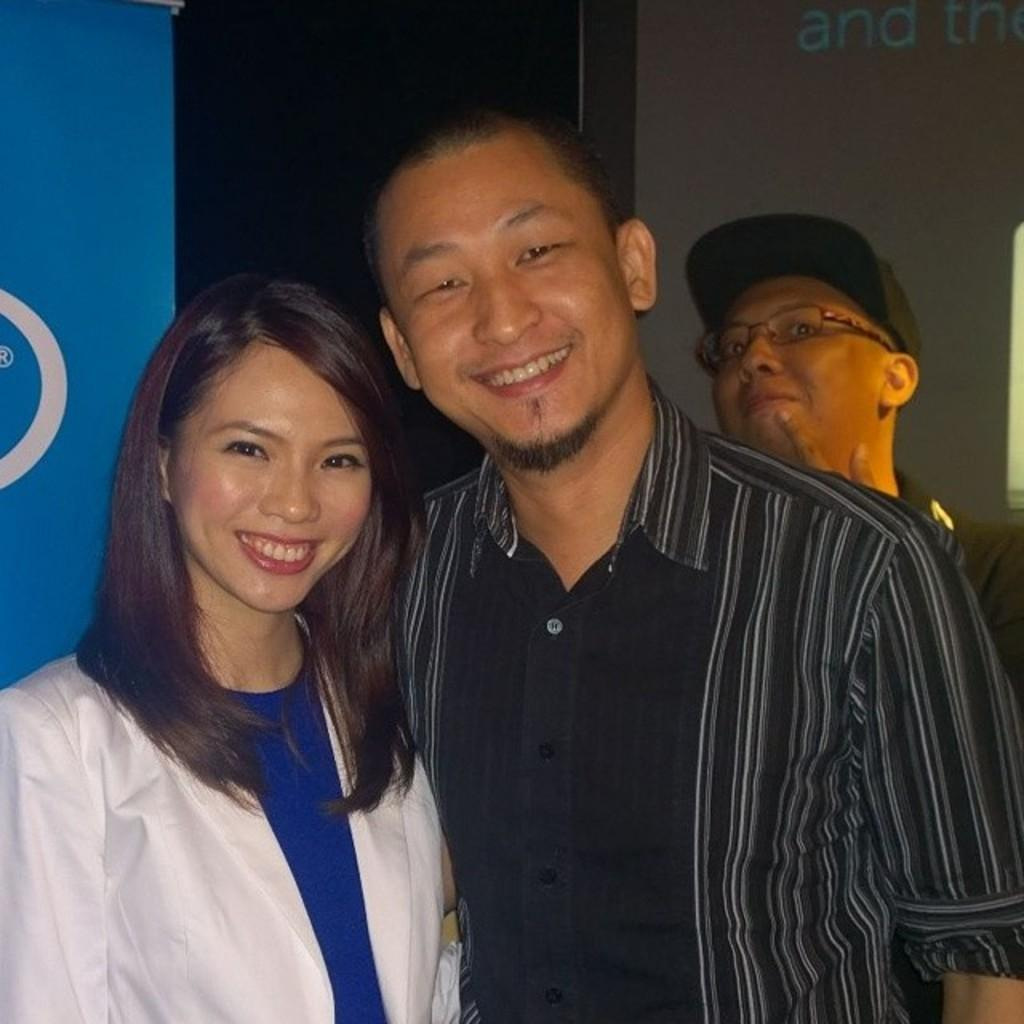How many people are present in the image? There are three people in the image. What are the people doing in the image? The people are standing and smiling. Can you describe the appearance of one of the individuals? There is a man wearing a spectacle and a cap. What can be seen in the background of the image? There are banners in the background of the image. What type of cakes are being served at the event in the image? There is no event or cakes present in the image; it features three people standing and smiling. Can you tell me how many hearts are visible in the image? There are no hearts visible in the image. 